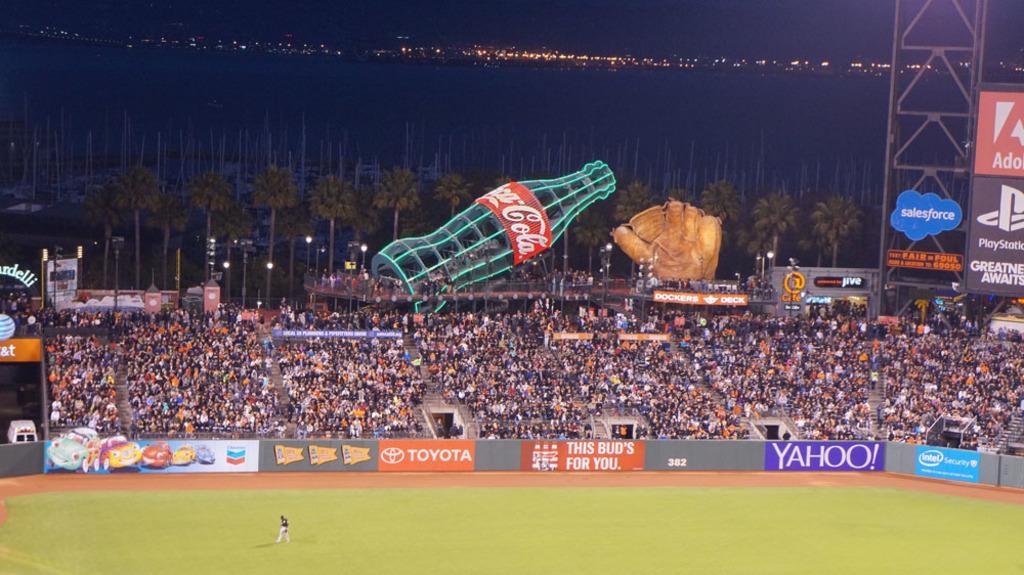Can you describe this image briefly? In this image, I can see groups of people. I think this is the stadium. I can see a person standing. This looks like a ground. I can see the hoardings. This looks like an advertising hoarding of a bottle. These are the boards attached to a pole. I can see the trees and poles. In the background, I can see the lights. 